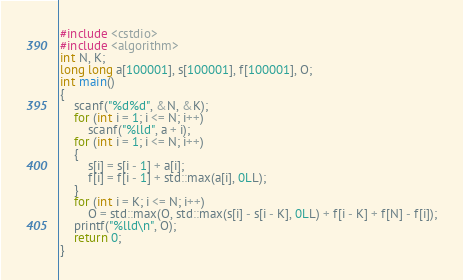<code> <loc_0><loc_0><loc_500><loc_500><_C++_>#include <cstdio>
#include <algorithm>
int N, K;
long long a[100001], s[100001], f[100001], O;
int main()
{
	scanf("%d%d", &N, &K);
	for (int i = 1; i <= N; i++)
		scanf("%lld", a + i);
	for (int i = 1; i <= N; i++)
	{
		s[i] = s[i - 1] + a[i];
		f[i] = f[i - 1] + std::max(a[i], 0LL);
	}
	for (int i = K; i <= N; i++)
		O = std::max(O, std::max(s[i] - s[i - K], 0LL) + f[i - K] + f[N] - f[i]);
	printf("%lld\n", O);
	return 0;
}
</code> 